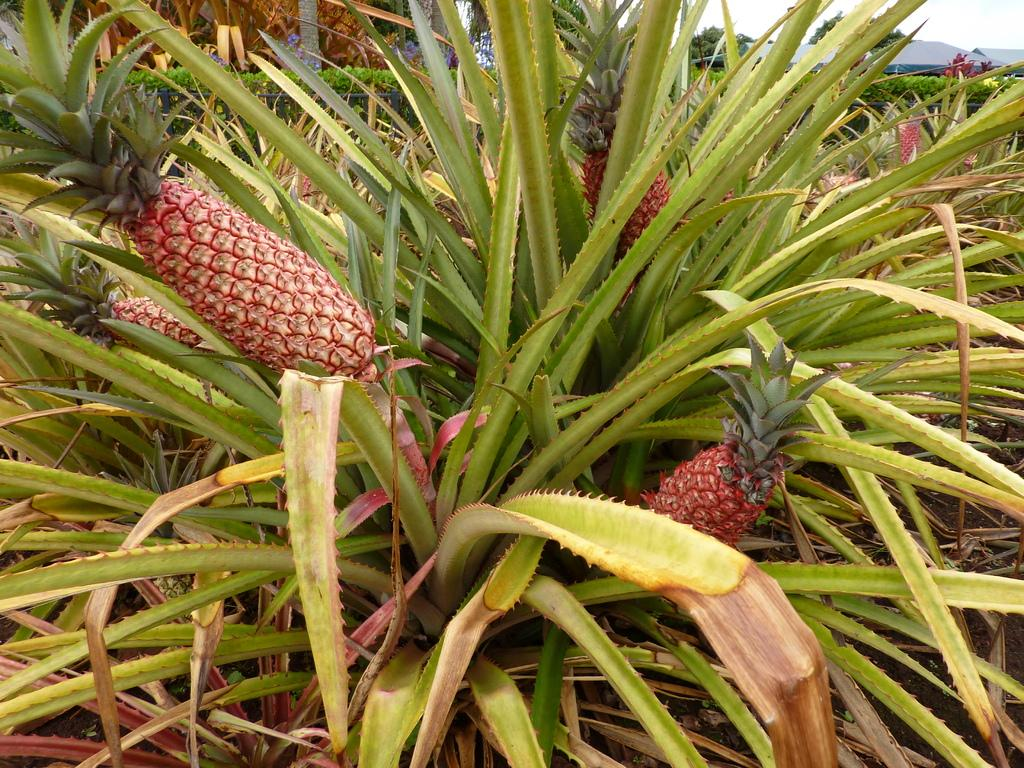What type of plants are in the image? There are pineapple plants in the image. What geographical feature can be seen in the background of the image? There is a mountain visible in the image. What part of the natural environment is visible in the image? The sky is visible in the image. How many oranges are hanging from the pineapple plants in the image? There are no oranges present in the image; it features pineapple plants. 